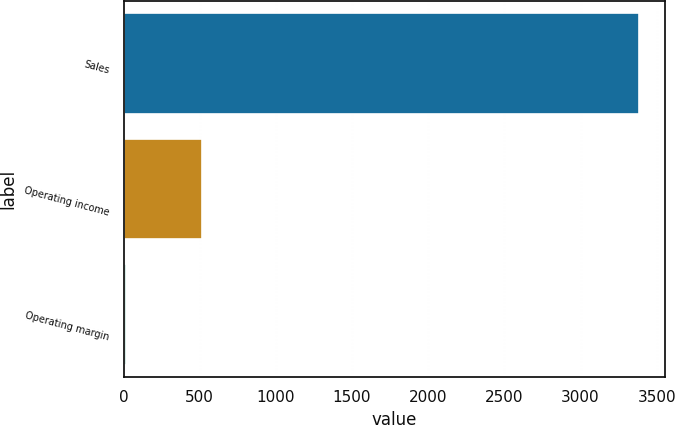Convert chart to OTSL. <chart><loc_0><loc_0><loc_500><loc_500><bar_chart><fcel>Sales<fcel>Operating income<fcel>Operating margin<nl><fcel>3387.3<fcel>515.9<fcel>15.2<nl></chart> 